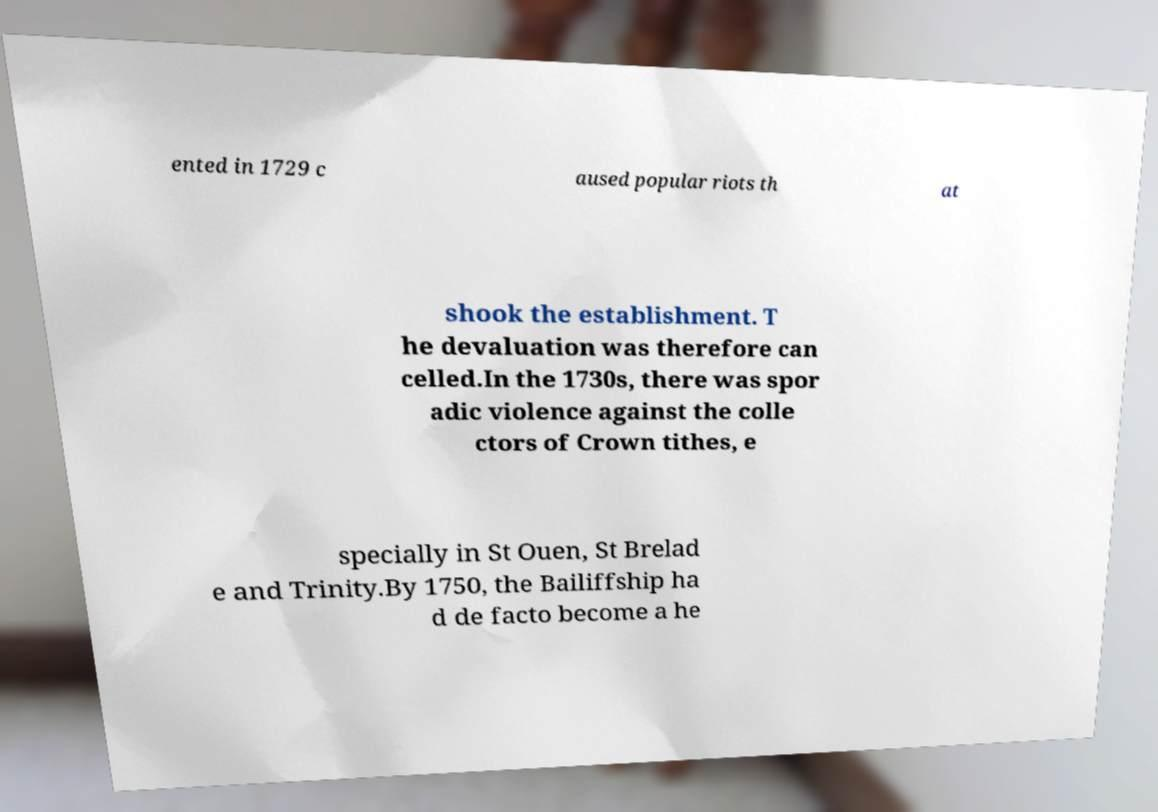Please identify and transcribe the text found in this image. ented in 1729 c aused popular riots th at shook the establishment. T he devaluation was therefore can celled.In the 1730s, there was spor adic violence against the colle ctors of Crown tithes, e specially in St Ouen, St Brelad e and Trinity.By 1750, the Bailiffship ha d de facto become a he 